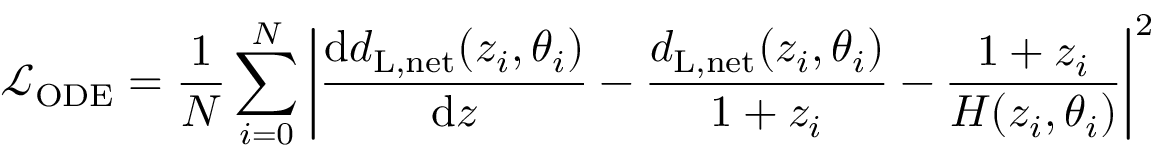Convert formula to latex. <formula><loc_0><loc_0><loc_500><loc_500>\mathcal { L } _ { O D E } = \frac { 1 } { N } \sum _ { i = 0 } ^ { N } \left | \frac { d d _ { L , n e t } ( z _ { i } , \theta _ { i } ) } { d z } - \frac { d _ { L , n e t } ( z _ { i } , \theta _ { i } ) } { 1 + z _ { i } } - \frac { 1 + z _ { i } } { H ( z _ { i } , \theta _ { i } ) } \right | ^ { 2 }</formula> 